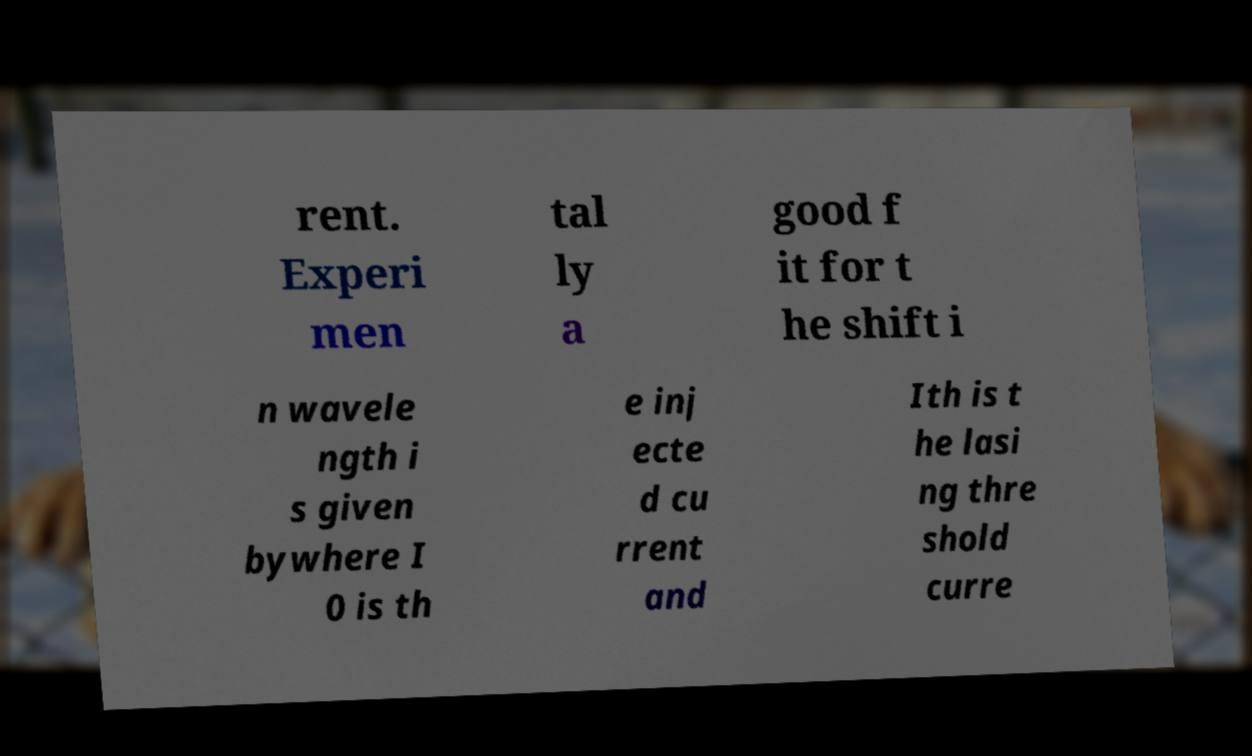What messages or text are displayed in this image? I need them in a readable, typed format. rent. Experi men tal ly a good f it for t he shift i n wavele ngth i s given bywhere I 0 is th e inj ecte d cu rrent and Ith is t he lasi ng thre shold curre 